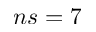<formula> <loc_0><loc_0><loc_500><loc_500>n s = 7</formula> 